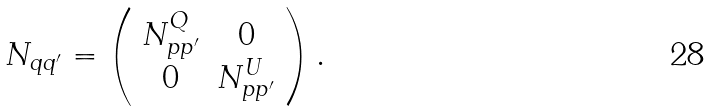<formula> <loc_0><loc_0><loc_500><loc_500>N _ { q q ^ { \prime } } = \left ( \begin{array} { c c } N ^ { Q } _ { p p ^ { \prime } } & { 0 } \\ { 0 } & N ^ { U } _ { p p ^ { \prime } } \end{array} \right ) .</formula> 